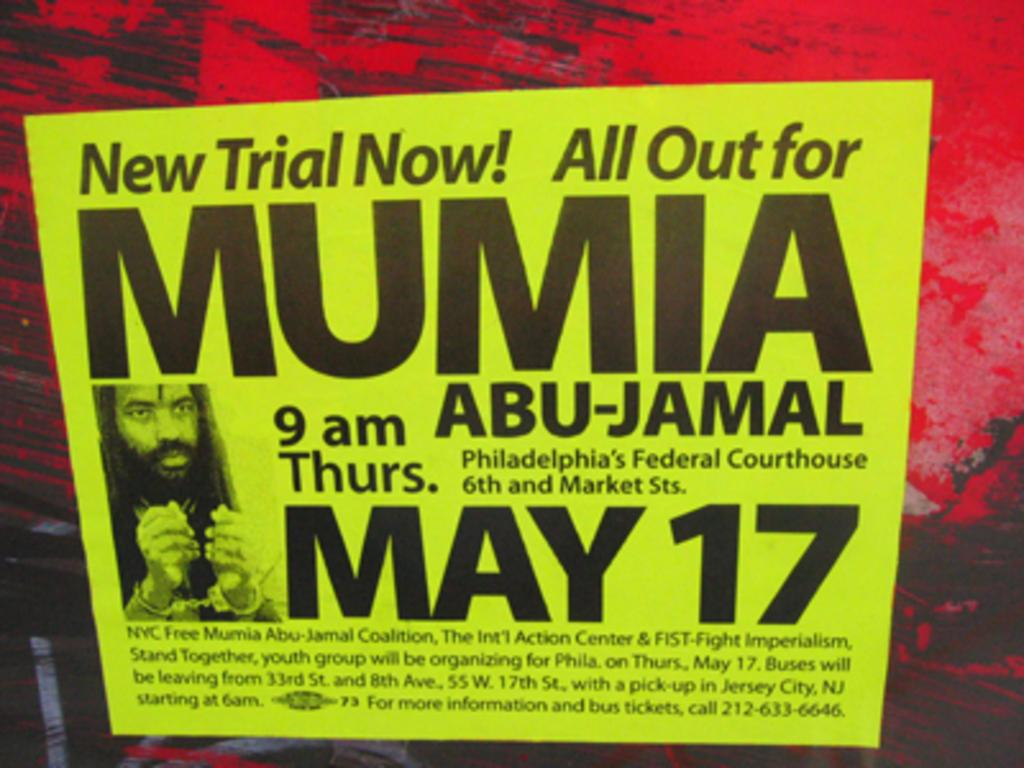<image>
Describe the image concisely. The poster talks about a new trial for Mumia Abu-Jamal. 